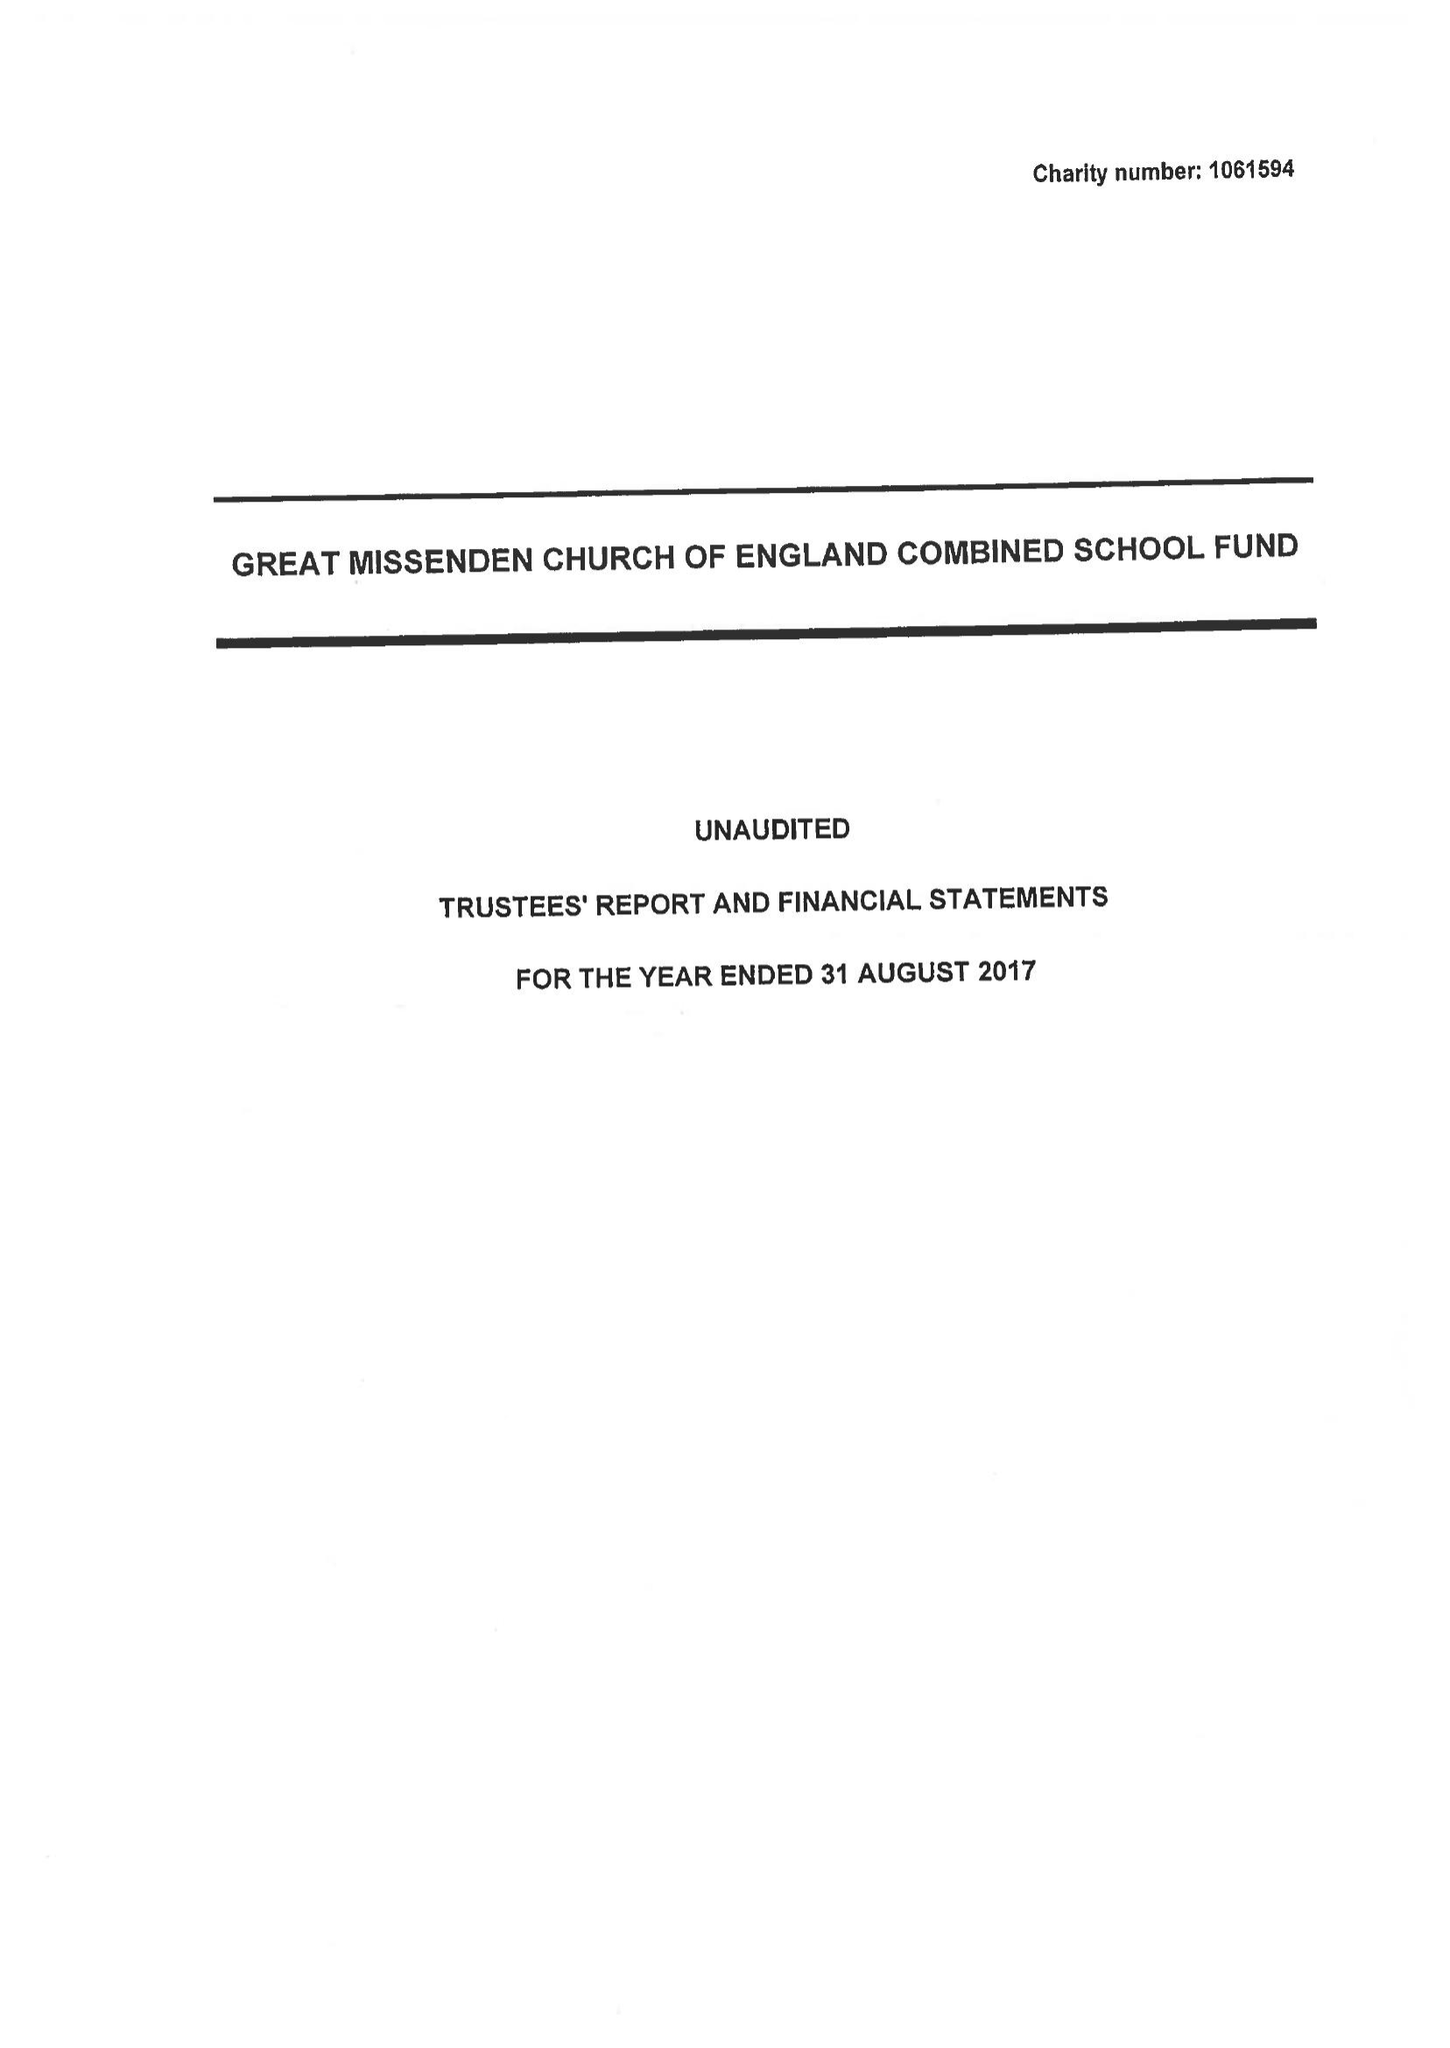What is the value for the report_date?
Answer the question using a single word or phrase. 2017-08-31 